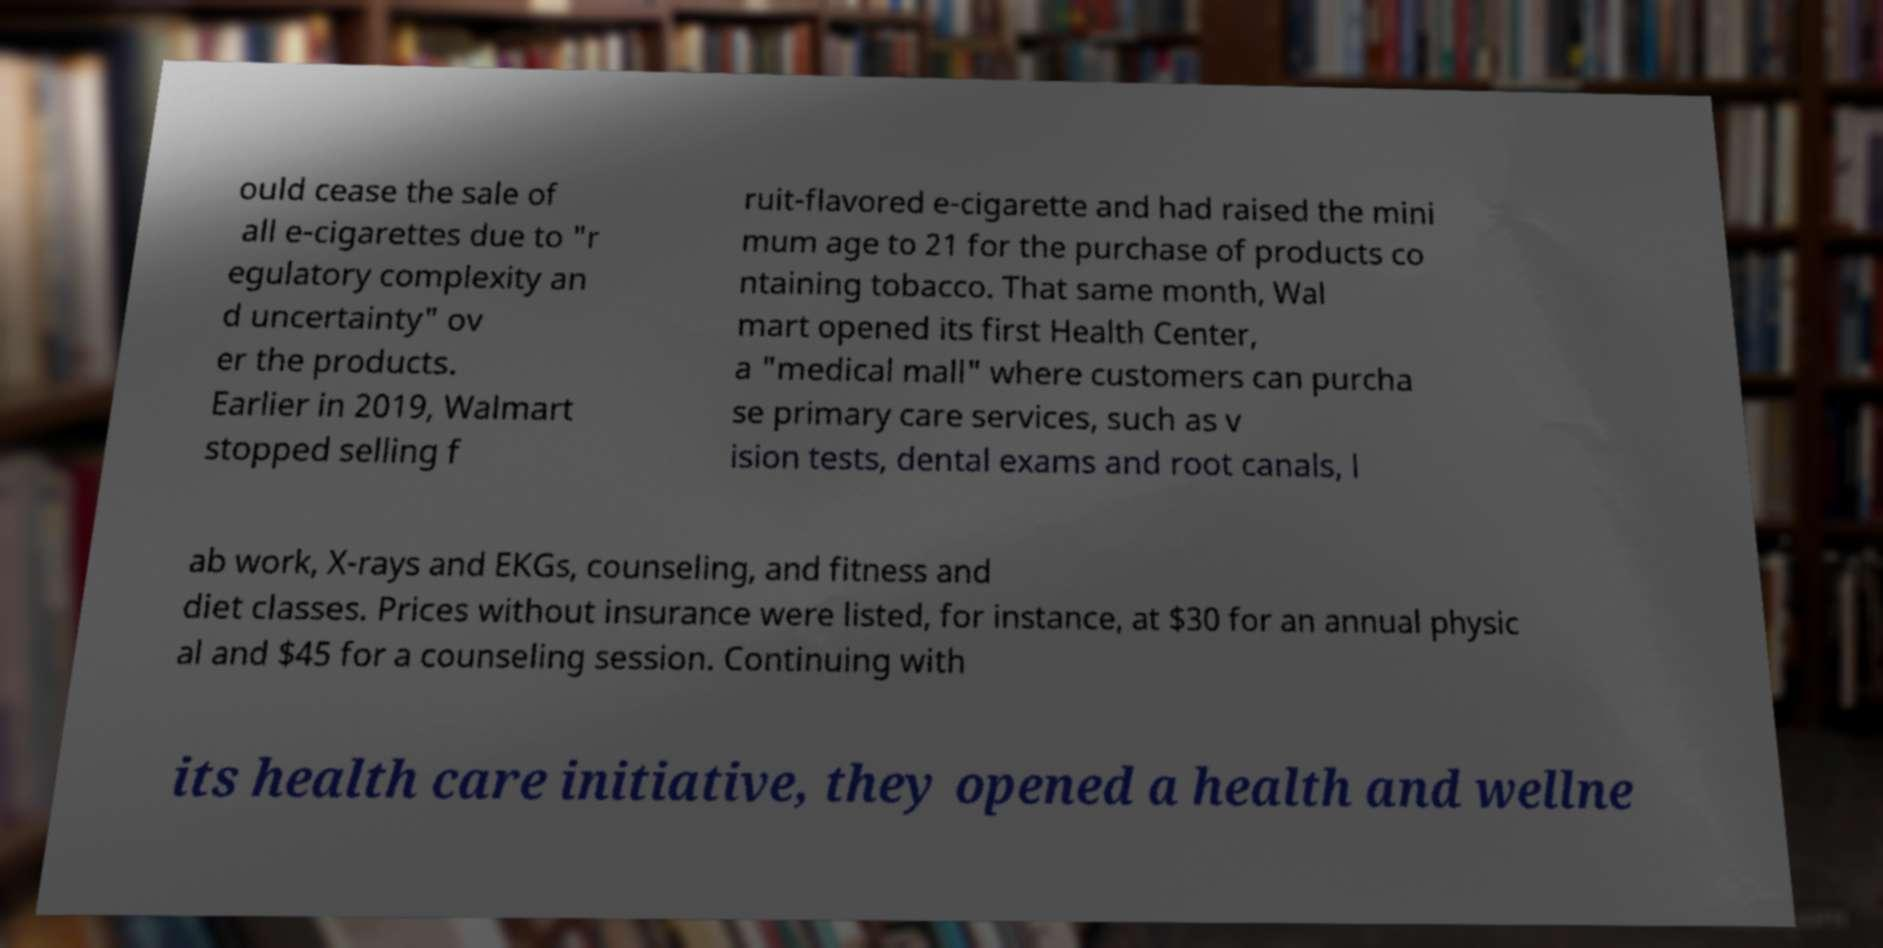What messages or text are displayed in this image? I need them in a readable, typed format. ould cease the sale of all e-cigarettes due to "r egulatory complexity an d uncertainty" ov er the products. Earlier in 2019, Walmart stopped selling f ruit-flavored e-cigarette and had raised the mini mum age to 21 for the purchase of products co ntaining tobacco. That same month, Wal mart opened its first Health Center, a "medical mall" where customers can purcha se primary care services, such as v ision tests, dental exams and root canals, l ab work, X-rays and EKGs, counseling, and fitness and diet classes. Prices without insurance were listed, for instance, at $30 for an annual physic al and $45 for a counseling session. Continuing with its health care initiative, they opened a health and wellne 